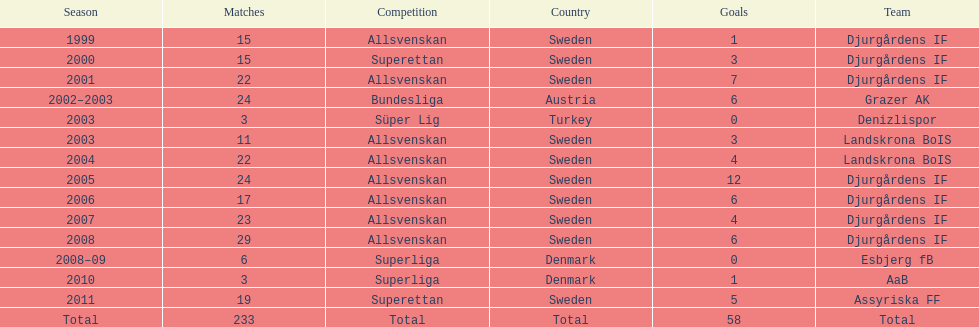How many matches overall were there? 233. 